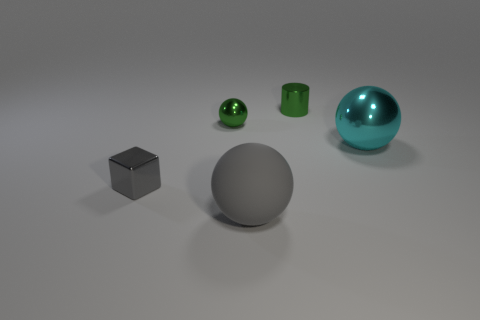What is the shape of the tiny shiny thing that is the same color as the tiny metal cylinder?
Provide a succinct answer. Sphere. There is a big metallic thing behind the gray matte ball; is its shape the same as the tiny gray object?
Provide a short and direct response. No. Is the number of balls that are behind the big cyan metal thing greater than the number of big brown metal objects?
Provide a short and direct response. Yes. The object that is both right of the small green ball and to the left of the cylinder is made of what material?
Provide a short and direct response. Rubber. Is there any other thing that is the same shape as the small gray thing?
Give a very brief answer. No. How many green metal objects are on the left side of the rubber ball and to the right of the large gray sphere?
Make the answer very short. 0. What material is the green ball?
Make the answer very short. Metal. Is the number of big gray rubber things to the left of the small gray metallic block the same as the number of small green shiny spheres?
Provide a short and direct response. No. How many purple metallic objects are the same shape as the big cyan metal thing?
Your response must be concise. 0. Do the big metallic thing and the rubber thing have the same shape?
Keep it short and to the point. Yes. 